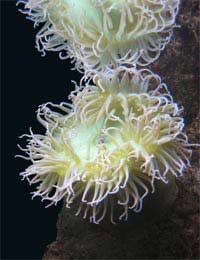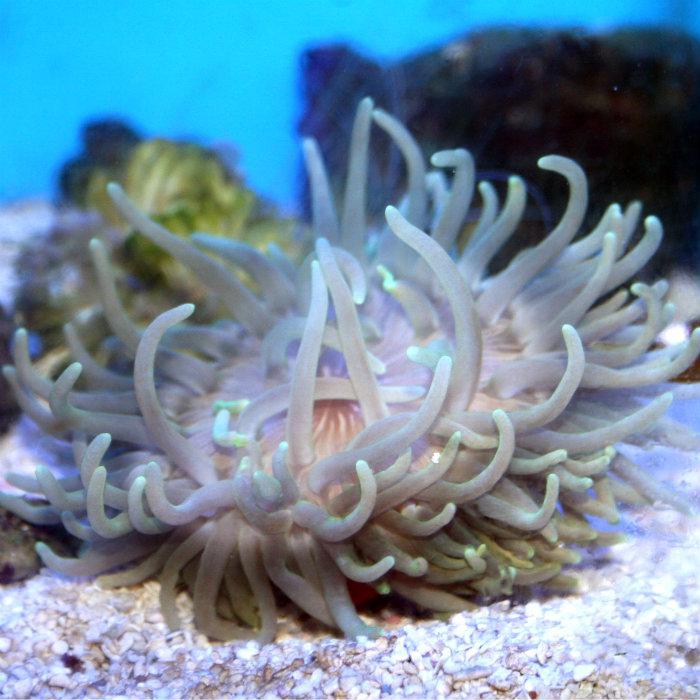The first image is the image on the left, the second image is the image on the right. Considering the images on both sides, is "An image features an anemone with pale tendrils and a rosy-orange body." valid? Answer yes or no. No. 